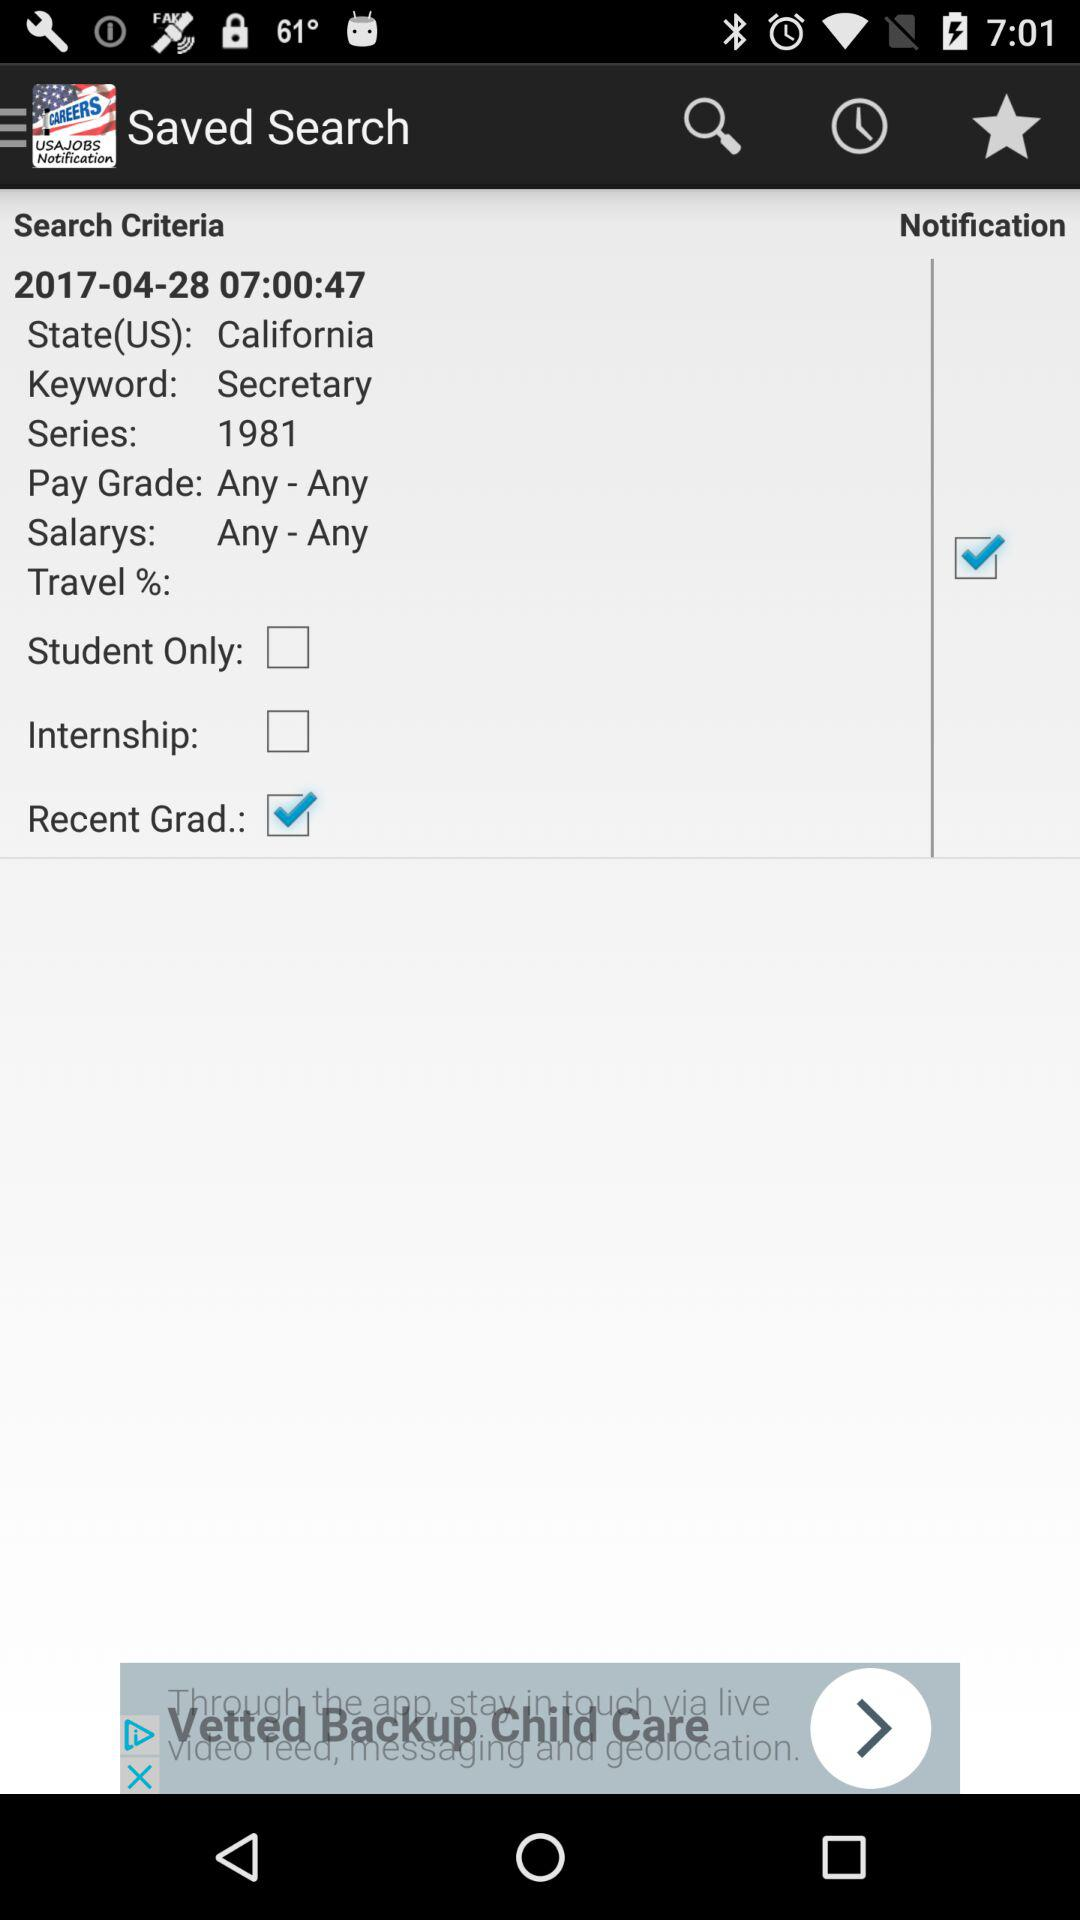What is the status of "Recent Grad."? The status is on. 